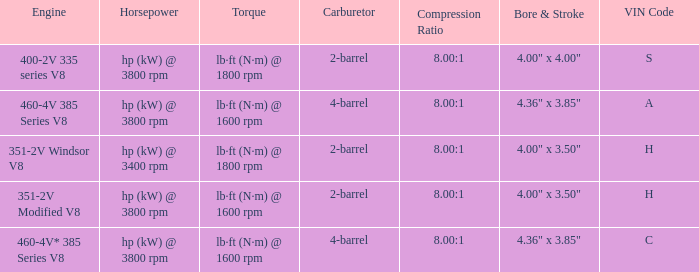What are the bore & stroke specifications for an engine with 4-barrel carburetor and VIN code of A? 4.36" x 3.85". 